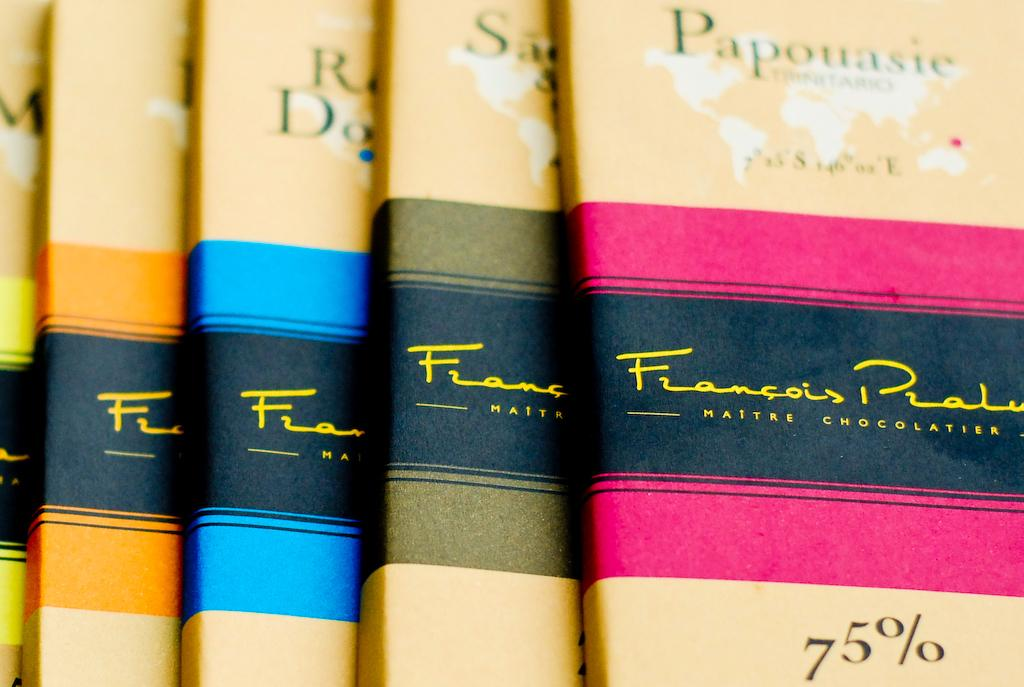<image>
Give a short and clear explanation of the subsequent image. The book with the pink stripe is called Papouasie 